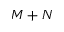<formula> <loc_0><loc_0><loc_500><loc_500>M + N</formula> 